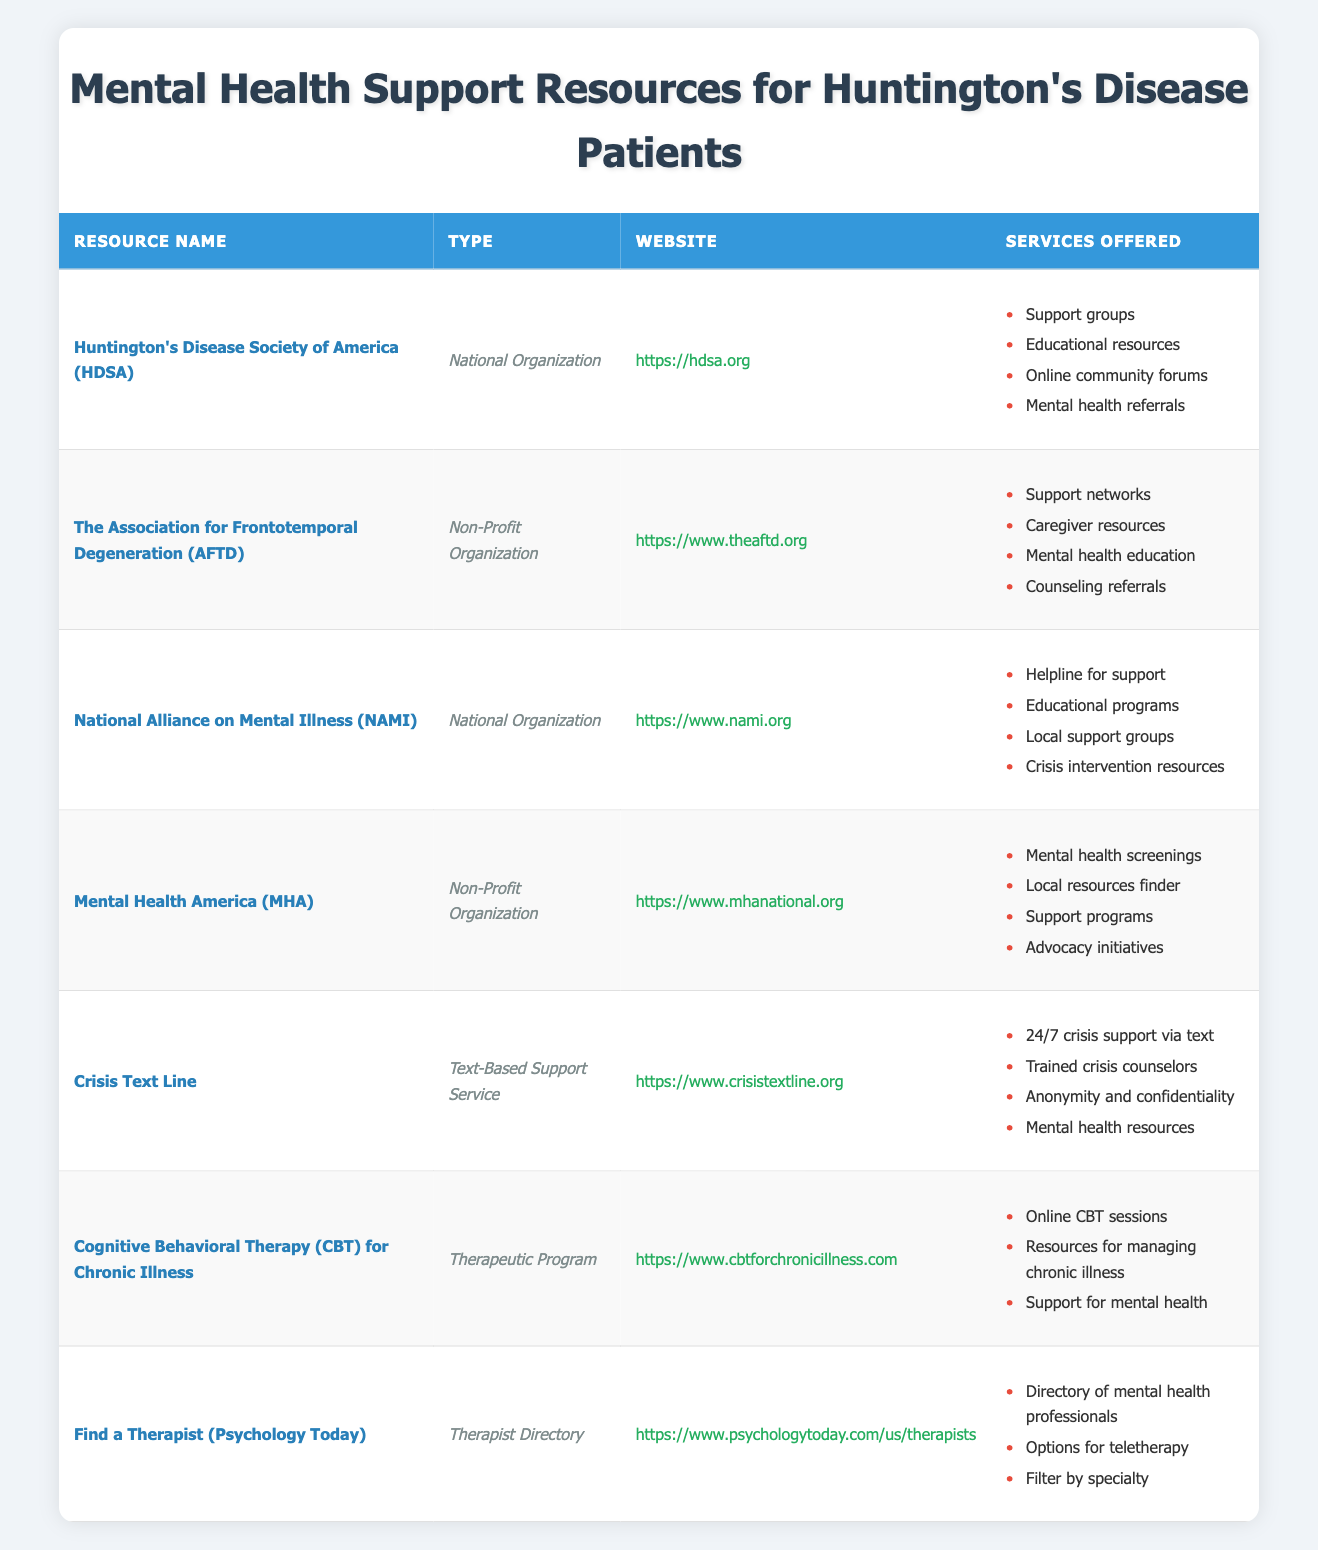What is the website for the Huntington's Disease Society of America? The table lists the website for HDSA under the "Website" column. It is stated as "https://hdsa.org."
Answer: https://hdsa.org How many types of mental health support resources are listed in the table? By analyzing the "Type" column, there are three distinct types: National Organization, Non-Profit Organization, Text-Based Support Service, and Therapeutic Program, totaling four unique types.
Answer: 4 Does Mental Health America offer mental health screenings? The services offered by Mental Health America, as listed in the table, include "Mental health screenings," confirming that they do offer this service.
Answer: Yes Which resource offers support networks? The table indicates that "The Association for Frontotemporal Degeneration (AFTD)" is the resource that offers "Support networks" among its services listed.
Answer: The Association for Frontotemporal Degeneration (AFTD) What is a common service provided by both the Huntington's Disease Society of America (HDSA) and the National Alliance on Mental Illness (NAMI)? Examining the services offered by both organizations reveals "Support groups" under HDSA and "Local support groups" under NAMI. Though phrased differently, they both feature support group services.
Answer: Support groups Which of these resources provides 24/7 crisis support? The table specifies that the "Crisis Text Line" provides "24/7 crisis support via text," indicating their availability around the clock for crisis situations.
Answer: Crisis Text Line What percentage of the resources listed are non-profit organizations? There are a total of 7 resources in the table, with 3 categorized as non-profit organizations (AFTD, MHA, and HDSA). The percentage is calculated as (3/7) * 100, which results in approximately 42.86%.
Answer: Approximately 42.86% Which resource has a focus on chronic illness management through Cognitive Behavioral Therapy? The table specifies "Cognitive Behavioral Therapy (CBT) for Chronic Illness" as the resource designed for managing chronic illnesses using CBT, identifying it directly.
Answer: Cognitive Behavioral Therapy (CBT) for Chronic Illness How many resources listed provide mental health referrals? According to the services listed, both the "Huntington's Disease Society of America (HDSA)" and "The Association for Frontotemporal Degeneration (AFTD)" offer mental health referrals, totaling two resources.
Answer: 2 Is there a service that allows finding a therapist online? The "Find a Therapist (Psychology Today)" resource is indicated in the table as providing a directory of mental health professionals, fulfilling the criteria for finding a therapist online.
Answer: Yes Which resource provides anonymity and confidentiality in their support? The "Crisis Text Line" explicitly states it offers "Anonymity and confidentiality," confirming their commitment to providing secure support for users.
Answer: Crisis Text Line 